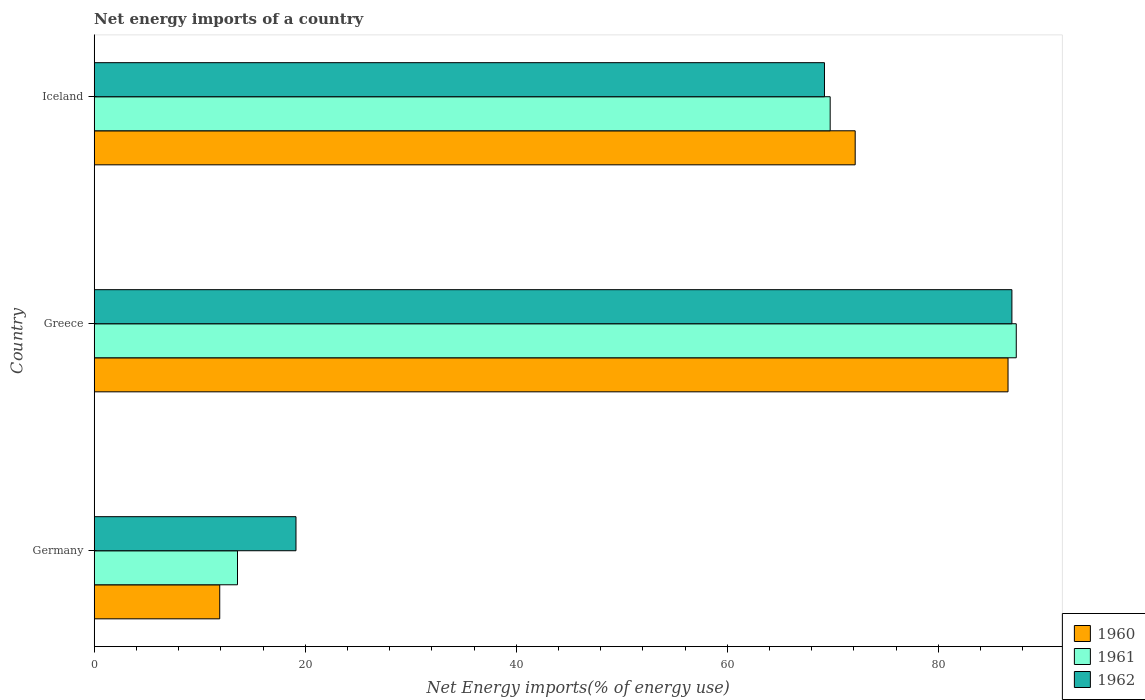Are the number of bars on each tick of the Y-axis equal?
Ensure brevity in your answer.  Yes. How many bars are there on the 3rd tick from the bottom?
Offer a very short reply. 3. What is the net energy imports in 1961 in Germany?
Provide a succinct answer. 13.58. Across all countries, what is the maximum net energy imports in 1961?
Your response must be concise. 87.4. Across all countries, what is the minimum net energy imports in 1961?
Your answer should be very brief. 13.58. In which country was the net energy imports in 1962 maximum?
Make the answer very short. Greece. What is the total net energy imports in 1962 in the graph?
Your answer should be compact. 175.33. What is the difference between the net energy imports in 1960 in Germany and that in Iceland?
Keep it short and to the point. -60.23. What is the difference between the net energy imports in 1960 in Germany and the net energy imports in 1962 in Iceland?
Keep it short and to the point. -57.32. What is the average net energy imports in 1960 per country?
Your answer should be very brief. 56.88. What is the difference between the net energy imports in 1962 and net energy imports in 1961 in Greece?
Your answer should be very brief. -0.41. What is the ratio of the net energy imports in 1961 in Greece to that in Iceland?
Provide a succinct answer. 1.25. Is the difference between the net energy imports in 1962 in Germany and Iceland greater than the difference between the net energy imports in 1961 in Germany and Iceland?
Your answer should be very brief. Yes. What is the difference between the highest and the second highest net energy imports in 1961?
Ensure brevity in your answer.  17.64. What is the difference between the highest and the lowest net energy imports in 1960?
Give a very brief answer. 74.72. In how many countries, is the net energy imports in 1961 greater than the average net energy imports in 1961 taken over all countries?
Keep it short and to the point. 2. Is the sum of the net energy imports in 1962 in Greece and Iceland greater than the maximum net energy imports in 1961 across all countries?
Give a very brief answer. Yes. Is it the case that in every country, the sum of the net energy imports in 1960 and net energy imports in 1961 is greater than the net energy imports in 1962?
Keep it short and to the point. Yes. How many bars are there?
Keep it short and to the point. 9. Are all the bars in the graph horizontal?
Offer a very short reply. Yes. What is the difference between two consecutive major ticks on the X-axis?
Your answer should be compact. 20. Are the values on the major ticks of X-axis written in scientific E-notation?
Your answer should be very brief. No. Does the graph contain grids?
Provide a succinct answer. No. Where does the legend appear in the graph?
Provide a short and direct response. Bottom right. What is the title of the graph?
Make the answer very short. Net energy imports of a country. What is the label or title of the X-axis?
Offer a terse response. Net Energy imports(% of energy use). What is the Net Energy imports(% of energy use) in 1960 in Germany?
Give a very brief answer. 11.9. What is the Net Energy imports(% of energy use) of 1961 in Germany?
Keep it short and to the point. 13.58. What is the Net Energy imports(% of energy use) in 1962 in Germany?
Offer a terse response. 19.13. What is the Net Energy imports(% of energy use) in 1960 in Greece?
Your answer should be compact. 86.62. What is the Net Energy imports(% of energy use) of 1961 in Greece?
Ensure brevity in your answer.  87.4. What is the Net Energy imports(% of energy use) in 1962 in Greece?
Provide a succinct answer. 86.98. What is the Net Energy imports(% of energy use) in 1960 in Iceland?
Your answer should be compact. 72.13. What is the Net Energy imports(% of energy use) in 1961 in Iceland?
Your answer should be compact. 69.76. What is the Net Energy imports(% of energy use) in 1962 in Iceland?
Provide a succinct answer. 69.22. Across all countries, what is the maximum Net Energy imports(% of energy use) of 1960?
Offer a very short reply. 86.62. Across all countries, what is the maximum Net Energy imports(% of energy use) in 1961?
Your answer should be compact. 87.4. Across all countries, what is the maximum Net Energy imports(% of energy use) in 1962?
Make the answer very short. 86.98. Across all countries, what is the minimum Net Energy imports(% of energy use) in 1960?
Your response must be concise. 11.9. Across all countries, what is the minimum Net Energy imports(% of energy use) in 1961?
Your response must be concise. 13.58. Across all countries, what is the minimum Net Energy imports(% of energy use) of 1962?
Provide a short and direct response. 19.13. What is the total Net Energy imports(% of energy use) in 1960 in the graph?
Keep it short and to the point. 170.64. What is the total Net Energy imports(% of energy use) in 1961 in the graph?
Your answer should be compact. 170.73. What is the total Net Energy imports(% of energy use) of 1962 in the graph?
Make the answer very short. 175.33. What is the difference between the Net Energy imports(% of energy use) of 1960 in Germany and that in Greece?
Offer a very short reply. -74.72. What is the difference between the Net Energy imports(% of energy use) in 1961 in Germany and that in Greece?
Your answer should be very brief. -73.81. What is the difference between the Net Energy imports(% of energy use) in 1962 in Germany and that in Greece?
Make the answer very short. -67.86. What is the difference between the Net Energy imports(% of energy use) in 1960 in Germany and that in Iceland?
Ensure brevity in your answer.  -60.23. What is the difference between the Net Energy imports(% of energy use) of 1961 in Germany and that in Iceland?
Give a very brief answer. -56.17. What is the difference between the Net Energy imports(% of energy use) of 1962 in Germany and that in Iceland?
Your response must be concise. -50.09. What is the difference between the Net Energy imports(% of energy use) in 1960 in Greece and that in Iceland?
Your answer should be compact. 14.49. What is the difference between the Net Energy imports(% of energy use) of 1961 in Greece and that in Iceland?
Your answer should be very brief. 17.64. What is the difference between the Net Energy imports(% of energy use) in 1962 in Greece and that in Iceland?
Offer a very short reply. 17.77. What is the difference between the Net Energy imports(% of energy use) of 1960 in Germany and the Net Energy imports(% of energy use) of 1961 in Greece?
Offer a terse response. -75.5. What is the difference between the Net Energy imports(% of energy use) in 1960 in Germany and the Net Energy imports(% of energy use) in 1962 in Greece?
Your answer should be very brief. -75.08. What is the difference between the Net Energy imports(% of energy use) of 1961 in Germany and the Net Energy imports(% of energy use) of 1962 in Greece?
Your response must be concise. -73.4. What is the difference between the Net Energy imports(% of energy use) in 1960 in Germany and the Net Energy imports(% of energy use) in 1961 in Iceland?
Your answer should be compact. -57.86. What is the difference between the Net Energy imports(% of energy use) in 1960 in Germany and the Net Energy imports(% of energy use) in 1962 in Iceland?
Provide a short and direct response. -57.32. What is the difference between the Net Energy imports(% of energy use) of 1961 in Germany and the Net Energy imports(% of energy use) of 1962 in Iceland?
Offer a terse response. -55.63. What is the difference between the Net Energy imports(% of energy use) of 1960 in Greece and the Net Energy imports(% of energy use) of 1961 in Iceland?
Make the answer very short. 16.86. What is the difference between the Net Energy imports(% of energy use) in 1960 in Greece and the Net Energy imports(% of energy use) in 1962 in Iceland?
Give a very brief answer. 17.4. What is the difference between the Net Energy imports(% of energy use) of 1961 in Greece and the Net Energy imports(% of energy use) of 1962 in Iceland?
Keep it short and to the point. 18.18. What is the average Net Energy imports(% of energy use) of 1960 per country?
Your answer should be compact. 56.88. What is the average Net Energy imports(% of energy use) of 1961 per country?
Offer a terse response. 56.91. What is the average Net Energy imports(% of energy use) in 1962 per country?
Your answer should be compact. 58.44. What is the difference between the Net Energy imports(% of energy use) in 1960 and Net Energy imports(% of energy use) in 1961 in Germany?
Your answer should be compact. -1.68. What is the difference between the Net Energy imports(% of energy use) in 1960 and Net Energy imports(% of energy use) in 1962 in Germany?
Provide a succinct answer. -7.23. What is the difference between the Net Energy imports(% of energy use) of 1961 and Net Energy imports(% of energy use) of 1962 in Germany?
Make the answer very short. -5.54. What is the difference between the Net Energy imports(% of energy use) in 1960 and Net Energy imports(% of energy use) in 1961 in Greece?
Provide a succinct answer. -0.78. What is the difference between the Net Energy imports(% of energy use) in 1960 and Net Energy imports(% of energy use) in 1962 in Greece?
Keep it short and to the point. -0.37. What is the difference between the Net Energy imports(% of energy use) of 1961 and Net Energy imports(% of energy use) of 1962 in Greece?
Your answer should be compact. 0.41. What is the difference between the Net Energy imports(% of energy use) of 1960 and Net Energy imports(% of energy use) of 1961 in Iceland?
Keep it short and to the point. 2.37. What is the difference between the Net Energy imports(% of energy use) in 1960 and Net Energy imports(% of energy use) in 1962 in Iceland?
Make the answer very short. 2.91. What is the difference between the Net Energy imports(% of energy use) of 1961 and Net Energy imports(% of energy use) of 1962 in Iceland?
Give a very brief answer. 0.54. What is the ratio of the Net Energy imports(% of energy use) of 1960 in Germany to that in Greece?
Give a very brief answer. 0.14. What is the ratio of the Net Energy imports(% of energy use) in 1961 in Germany to that in Greece?
Provide a succinct answer. 0.16. What is the ratio of the Net Energy imports(% of energy use) of 1962 in Germany to that in Greece?
Keep it short and to the point. 0.22. What is the ratio of the Net Energy imports(% of energy use) in 1960 in Germany to that in Iceland?
Your answer should be compact. 0.17. What is the ratio of the Net Energy imports(% of energy use) of 1961 in Germany to that in Iceland?
Provide a short and direct response. 0.19. What is the ratio of the Net Energy imports(% of energy use) of 1962 in Germany to that in Iceland?
Give a very brief answer. 0.28. What is the ratio of the Net Energy imports(% of energy use) of 1960 in Greece to that in Iceland?
Ensure brevity in your answer.  1.2. What is the ratio of the Net Energy imports(% of energy use) of 1961 in Greece to that in Iceland?
Your answer should be compact. 1.25. What is the ratio of the Net Energy imports(% of energy use) in 1962 in Greece to that in Iceland?
Your answer should be very brief. 1.26. What is the difference between the highest and the second highest Net Energy imports(% of energy use) of 1960?
Offer a terse response. 14.49. What is the difference between the highest and the second highest Net Energy imports(% of energy use) in 1961?
Give a very brief answer. 17.64. What is the difference between the highest and the second highest Net Energy imports(% of energy use) of 1962?
Provide a succinct answer. 17.77. What is the difference between the highest and the lowest Net Energy imports(% of energy use) of 1960?
Offer a terse response. 74.72. What is the difference between the highest and the lowest Net Energy imports(% of energy use) of 1961?
Offer a very short reply. 73.81. What is the difference between the highest and the lowest Net Energy imports(% of energy use) of 1962?
Your answer should be compact. 67.86. 